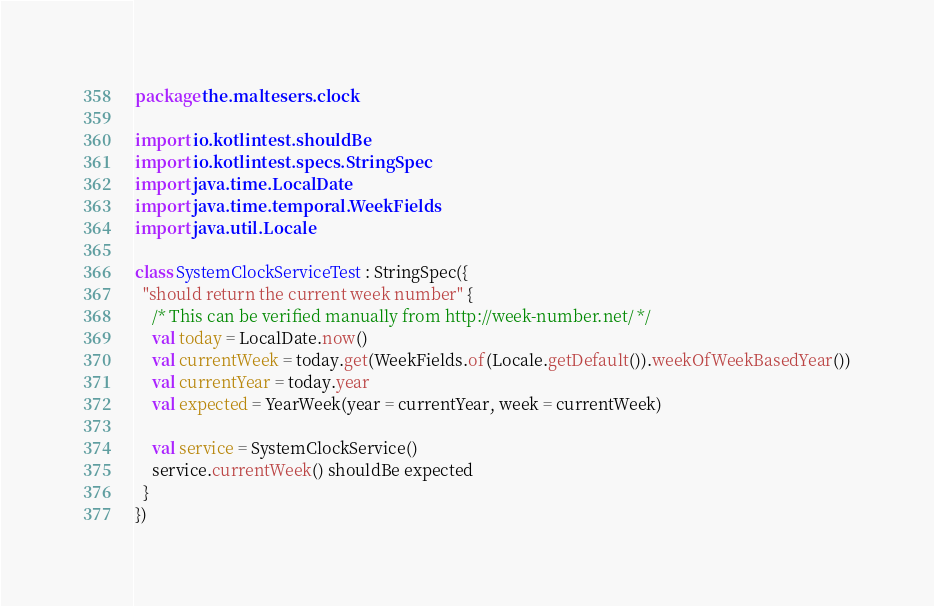<code> <loc_0><loc_0><loc_500><loc_500><_Kotlin_>package the.maltesers.clock

import io.kotlintest.shouldBe
import io.kotlintest.specs.StringSpec
import java.time.LocalDate
import java.time.temporal.WeekFields
import java.util.Locale

class SystemClockServiceTest : StringSpec({
  "should return the current week number" {
    /* This can be verified manually from http://week-number.net/ */
    val today = LocalDate.now()
    val currentWeek = today.get(WeekFields.of(Locale.getDefault()).weekOfWeekBasedYear())
    val currentYear = today.year
    val expected = YearWeek(year = currentYear, week = currentWeek)

    val service = SystemClockService()
    service.currentWeek() shouldBe expected
  }
})
</code> 